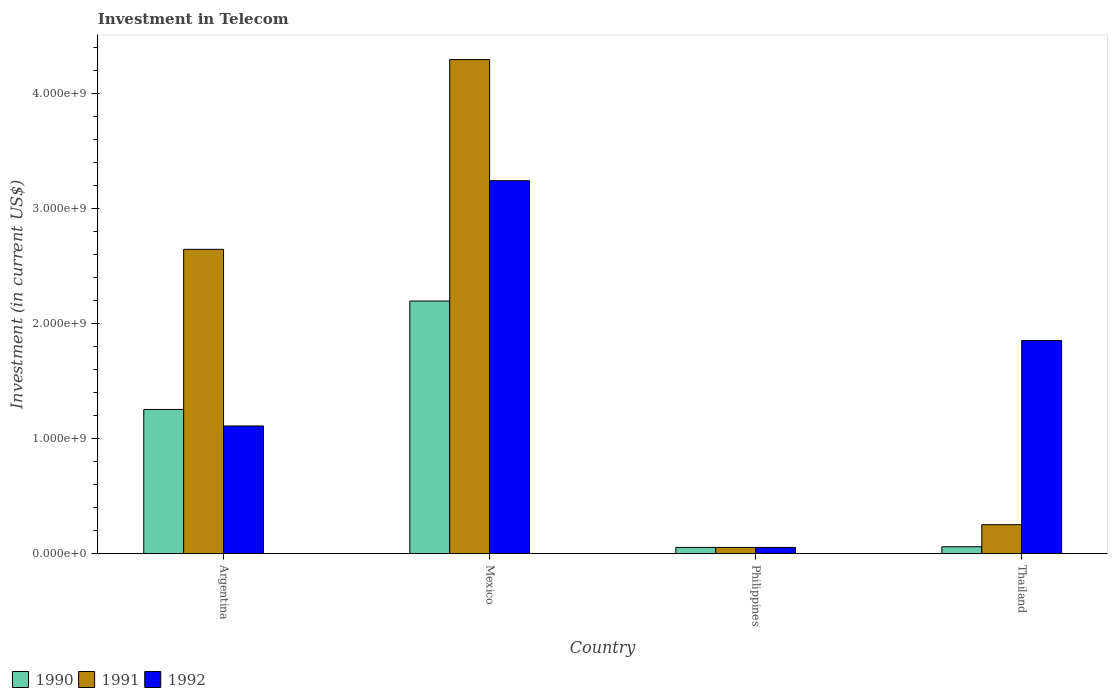How many groups of bars are there?
Your answer should be compact. 4. Are the number of bars per tick equal to the number of legend labels?
Your answer should be compact. Yes. What is the amount invested in telecom in 1992 in Philippines?
Your answer should be very brief. 5.42e+07. Across all countries, what is the maximum amount invested in telecom in 1991?
Provide a short and direct response. 4.30e+09. Across all countries, what is the minimum amount invested in telecom in 1991?
Offer a very short reply. 5.42e+07. In which country was the amount invested in telecom in 1992 minimum?
Offer a terse response. Philippines. What is the total amount invested in telecom in 1991 in the graph?
Make the answer very short. 7.25e+09. What is the difference between the amount invested in telecom in 1991 in Argentina and that in Philippines?
Keep it short and to the point. 2.59e+09. What is the difference between the amount invested in telecom in 1990 in Thailand and the amount invested in telecom in 1992 in Argentina?
Ensure brevity in your answer.  -1.05e+09. What is the average amount invested in telecom in 1991 per country?
Make the answer very short. 1.81e+09. What is the difference between the amount invested in telecom of/in 1990 and amount invested in telecom of/in 1991 in Argentina?
Provide a succinct answer. -1.39e+09. In how many countries, is the amount invested in telecom in 1990 greater than 1200000000 US$?
Give a very brief answer. 2. What is the ratio of the amount invested in telecom in 1992 in Argentina to that in Thailand?
Offer a very short reply. 0.6. Is the amount invested in telecom in 1991 in Mexico less than that in Philippines?
Your response must be concise. No. What is the difference between the highest and the second highest amount invested in telecom in 1992?
Ensure brevity in your answer.  1.39e+09. What is the difference between the highest and the lowest amount invested in telecom in 1991?
Provide a succinct answer. 4.24e+09. In how many countries, is the amount invested in telecom in 1991 greater than the average amount invested in telecom in 1991 taken over all countries?
Give a very brief answer. 2. Is the sum of the amount invested in telecom in 1992 in Mexico and Philippines greater than the maximum amount invested in telecom in 1991 across all countries?
Give a very brief answer. No. Is it the case that in every country, the sum of the amount invested in telecom in 1990 and amount invested in telecom in 1992 is greater than the amount invested in telecom in 1991?
Keep it short and to the point. No. Are all the bars in the graph horizontal?
Your response must be concise. No. How many countries are there in the graph?
Provide a short and direct response. 4. Does the graph contain any zero values?
Offer a very short reply. No. Does the graph contain grids?
Provide a succinct answer. No. Where does the legend appear in the graph?
Your response must be concise. Bottom left. What is the title of the graph?
Offer a very short reply. Investment in Telecom. Does "2011" appear as one of the legend labels in the graph?
Make the answer very short. No. What is the label or title of the Y-axis?
Keep it short and to the point. Investment (in current US$). What is the Investment (in current US$) in 1990 in Argentina?
Provide a short and direct response. 1.25e+09. What is the Investment (in current US$) in 1991 in Argentina?
Your response must be concise. 2.65e+09. What is the Investment (in current US$) of 1992 in Argentina?
Offer a very short reply. 1.11e+09. What is the Investment (in current US$) of 1990 in Mexico?
Your answer should be very brief. 2.20e+09. What is the Investment (in current US$) of 1991 in Mexico?
Provide a short and direct response. 4.30e+09. What is the Investment (in current US$) in 1992 in Mexico?
Offer a terse response. 3.24e+09. What is the Investment (in current US$) of 1990 in Philippines?
Make the answer very short. 5.42e+07. What is the Investment (in current US$) of 1991 in Philippines?
Provide a short and direct response. 5.42e+07. What is the Investment (in current US$) in 1992 in Philippines?
Keep it short and to the point. 5.42e+07. What is the Investment (in current US$) in 1990 in Thailand?
Provide a short and direct response. 6.00e+07. What is the Investment (in current US$) of 1991 in Thailand?
Provide a succinct answer. 2.52e+08. What is the Investment (in current US$) in 1992 in Thailand?
Provide a succinct answer. 1.85e+09. Across all countries, what is the maximum Investment (in current US$) in 1990?
Offer a terse response. 2.20e+09. Across all countries, what is the maximum Investment (in current US$) in 1991?
Give a very brief answer. 4.30e+09. Across all countries, what is the maximum Investment (in current US$) in 1992?
Provide a short and direct response. 3.24e+09. Across all countries, what is the minimum Investment (in current US$) of 1990?
Your answer should be very brief. 5.42e+07. Across all countries, what is the minimum Investment (in current US$) of 1991?
Give a very brief answer. 5.42e+07. Across all countries, what is the minimum Investment (in current US$) in 1992?
Offer a terse response. 5.42e+07. What is the total Investment (in current US$) of 1990 in the graph?
Your answer should be compact. 3.57e+09. What is the total Investment (in current US$) of 1991 in the graph?
Your answer should be compact. 7.25e+09. What is the total Investment (in current US$) of 1992 in the graph?
Your answer should be very brief. 6.26e+09. What is the difference between the Investment (in current US$) in 1990 in Argentina and that in Mexico?
Ensure brevity in your answer.  -9.43e+08. What is the difference between the Investment (in current US$) in 1991 in Argentina and that in Mexico?
Provide a short and direct response. -1.65e+09. What is the difference between the Investment (in current US$) in 1992 in Argentina and that in Mexico?
Your response must be concise. -2.13e+09. What is the difference between the Investment (in current US$) of 1990 in Argentina and that in Philippines?
Your response must be concise. 1.20e+09. What is the difference between the Investment (in current US$) in 1991 in Argentina and that in Philippines?
Provide a succinct answer. 2.59e+09. What is the difference between the Investment (in current US$) in 1992 in Argentina and that in Philippines?
Ensure brevity in your answer.  1.06e+09. What is the difference between the Investment (in current US$) of 1990 in Argentina and that in Thailand?
Give a very brief answer. 1.19e+09. What is the difference between the Investment (in current US$) of 1991 in Argentina and that in Thailand?
Keep it short and to the point. 2.40e+09. What is the difference between the Investment (in current US$) in 1992 in Argentina and that in Thailand?
Offer a terse response. -7.43e+08. What is the difference between the Investment (in current US$) of 1990 in Mexico and that in Philippines?
Give a very brief answer. 2.14e+09. What is the difference between the Investment (in current US$) in 1991 in Mexico and that in Philippines?
Provide a succinct answer. 4.24e+09. What is the difference between the Investment (in current US$) in 1992 in Mexico and that in Philippines?
Provide a succinct answer. 3.19e+09. What is the difference between the Investment (in current US$) of 1990 in Mexico and that in Thailand?
Provide a short and direct response. 2.14e+09. What is the difference between the Investment (in current US$) in 1991 in Mexico and that in Thailand?
Provide a succinct answer. 4.05e+09. What is the difference between the Investment (in current US$) of 1992 in Mexico and that in Thailand?
Offer a very short reply. 1.39e+09. What is the difference between the Investment (in current US$) in 1990 in Philippines and that in Thailand?
Give a very brief answer. -5.80e+06. What is the difference between the Investment (in current US$) of 1991 in Philippines and that in Thailand?
Provide a short and direct response. -1.98e+08. What is the difference between the Investment (in current US$) of 1992 in Philippines and that in Thailand?
Ensure brevity in your answer.  -1.80e+09. What is the difference between the Investment (in current US$) in 1990 in Argentina and the Investment (in current US$) in 1991 in Mexico?
Provide a succinct answer. -3.04e+09. What is the difference between the Investment (in current US$) in 1990 in Argentina and the Investment (in current US$) in 1992 in Mexico?
Make the answer very short. -1.99e+09. What is the difference between the Investment (in current US$) of 1991 in Argentina and the Investment (in current US$) of 1992 in Mexico?
Ensure brevity in your answer.  -5.97e+08. What is the difference between the Investment (in current US$) in 1990 in Argentina and the Investment (in current US$) in 1991 in Philippines?
Offer a terse response. 1.20e+09. What is the difference between the Investment (in current US$) in 1990 in Argentina and the Investment (in current US$) in 1992 in Philippines?
Offer a very short reply. 1.20e+09. What is the difference between the Investment (in current US$) in 1991 in Argentina and the Investment (in current US$) in 1992 in Philippines?
Offer a very short reply. 2.59e+09. What is the difference between the Investment (in current US$) of 1990 in Argentina and the Investment (in current US$) of 1991 in Thailand?
Your answer should be very brief. 1.00e+09. What is the difference between the Investment (in current US$) of 1990 in Argentina and the Investment (in current US$) of 1992 in Thailand?
Give a very brief answer. -5.99e+08. What is the difference between the Investment (in current US$) in 1991 in Argentina and the Investment (in current US$) in 1992 in Thailand?
Your answer should be very brief. 7.94e+08. What is the difference between the Investment (in current US$) of 1990 in Mexico and the Investment (in current US$) of 1991 in Philippines?
Keep it short and to the point. 2.14e+09. What is the difference between the Investment (in current US$) of 1990 in Mexico and the Investment (in current US$) of 1992 in Philippines?
Your answer should be very brief. 2.14e+09. What is the difference between the Investment (in current US$) of 1991 in Mexico and the Investment (in current US$) of 1992 in Philippines?
Offer a terse response. 4.24e+09. What is the difference between the Investment (in current US$) of 1990 in Mexico and the Investment (in current US$) of 1991 in Thailand?
Your response must be concise. 1.95e+09. What is the difference between the Investment (in current US$) in 1990 in Mexico and the Investment (in current US$) in 1992 in Thailand?
Your answer should be very brief. 3.44e+08. What is the difference between the Investment (in current US$) of 1991 in Mexico and the Investment (in current US$) of 1992 in Thailand?
Your response must be concise. 2.44e+09. What is the difference between the Investment (in current US$) in 1990 in Philippines and the Investment (in current US$) in 1991 in Thailand?
Provide a short and direct response. -1.98e+08. What is the difference between the Investment (in current US$) in 1990 in Philippines and the Investment (in current US$) in 1992 in Thailand?
Give a very brief answer. -1.80e+09. What is the difference between the Investment (in current US$) of 1991 in Philippines and the Investment (in current US$) of 1992 in Thailand?
Provide a short and direct response. -1.80e+09. What is the average Investment (in current US$) in 1990 per country?
Keep it short and to the point. 8.92e+08. What is the average Investment (in current US$) in 1991 per country?
Provide a succinct answer. 1.81e+09. What is the average Investment (in current US$) of 1992 per country?
Provide a succinct answer. 1.57e+09. What is the difference between the Investment (in current US$) in 1990 and Investment (in current US$) in 1991 in Argentina?
Give a very brief answer. -1.39e+09. What is the difference between the Investment (in current US$) in 1990 and Investment (in current US$) in 1992 in Argentina?
Your answer should be compact. 1.44e+08. What is the difference between the Investment (in current US$) in 1991 and Investment (in current US$) in 1992 in Argentina?
Provide a succinct answer. 1.54e+09. What is the difference between the Investment (in current US$) of 1990 and Investment (in current US$) of 1991 in Mexico?
Your answer should be very brief. -2.10e+09. What is the difference between the Investment (in current US$) of 1990 and Investment (in current US$) of 1992 in Mexico?
Offer a very short reply. -1.05e+09. What is the difference between the Investment (in current US$) in 1991 and Investment (in current US$) in 1992 in Mexico?
Your response must be concise. 1.05e+09. What is the difference between the Investment (in current US$) in 1990 and Investment (in current US$) in 1991 in Philippines?
Offer a terse response. 0. What is the difference between the Investment (in current US$) in 1990 and Investment (in current US$) in 1992 in Philippines?
Offer a terse response. 0. What is the difference between the Investment (in current US$) in 1991 and Investment (in current US$) in 1992 in Philippines?
Your answer should be compact. 0. What is the difference between the Investment (in current US$) in 1990 and Investment (in current US$) in 1991 in Thailand?
Offer a very short reply. -1.92e+08. What is the difference between the Investment (in current US$) of 1990 and Investment (in current US$) of 1992 in Thailand?
Keep it short and to the point. -1.79e+09. What is the difference between the Investment (in current US$) in 1991 and Investment (in current US$) in 1992 in Thailand?
Make the answer very short. -1.60e+09. What is the ratio of the Investment (in current US$) in 1990 in Argentina to that in Mexico?
Keep it short and to the point. 0.57. What is the ratio of the Investment (in current US$) in 1991 in Argentina to that in Mexico?
Offer a very short reply. 0.62. What is the ratio of the Investment (in current US$) of 1992 in Argentina to that in Mexico?
Your answer should be compact. 0.34. What is the ratio of the Investment (in current US$) of 1990 in Argentina to that in Philippines?
Provide a succinct answer. 23.15. What is the ratio of the Investment (in current US$) in 1991 in Argentina to that in Philippines?
Your answer should be compact. 48.86. What is the ratio of the Investment (in current US$) of 1992 in Argentina to that in Philippines?
Offer a terse response. 20.5. What is the ratio of the Investment (in current US$) in 1990 in Argentina to that in Thailand?
Give a very brief answer. 20.91. What is the ratio of the Investment (in current US$) of 1991 in Argentina to that in Thailand?
Keep it short and to the point. 10.51. What is the ratio of the Investment (in current US$) in 1992 in Argentina to that in Thailand?
Offer a very short reply. 0.6. What is the ratio of the Investment (in current US$) of 1990 in Mexico to that in Philippines?
Give a very brief answer. 40.55. What is the ratio of the Investment (in current US$) of 1991 in Mexico to that in Philippines?
Keep it short and to the point. 79.32. What is the ratio of the Investment (in current US$) in 1992 in Mexico to that in Philippines?
Your answer should be very brief. 59.87. What is the ratio of the Investment (in current US$) of 1990 in Mexico to that in Thailand?
Make the answer very short. 36.63. What is the ratio of the Investment (in current US$) in 1991 in Mexico to that in Thailand?
Your response must be concise. 17.06. What is the ratio of the Investment (in current US$) of 1992 in Mexico to that in Thailand?
Provide a short and direct response. 1.75. What is the ratio of the Investment (in current US$) of 1990 in Philippines to that in Thailand?
Offer a very short reply. 0.9. What is the ratio of the Investment (in current US$) of 1991 in Philippines to that in Thailand?
Your answer should be compact. 0.22. What is the ratio of the Investment (in current US$) in 1992 in Philippines to that in Thailand?
Your answer should be very brief. 0.03. What is the difference between the highest and the second highest Investment (in current US$) in 1990?
Offer a very short reply. 9.43e+08. What is the difference between the highest and the second highest Investment (in current US$) of 1991?
Your response must be concise. 1.65e+09. What is the difference between the highest and the second highest Investment (in current US$) in 1992?
Your answer should be very brief. 1.39e+09. What is the difference between the highest and the lowest Investment (in current US$) in 1990?
Offer a very short reply. 2.14e+09. What is the difference between the highest and the lowest Investment (in current US$) in 1991?
Keep it short and to the point. 4.24e+09. What is the difference between the highest and the lowest Investment (in current US$) of 1992?
Your response must be concise. 3.19e+09. 